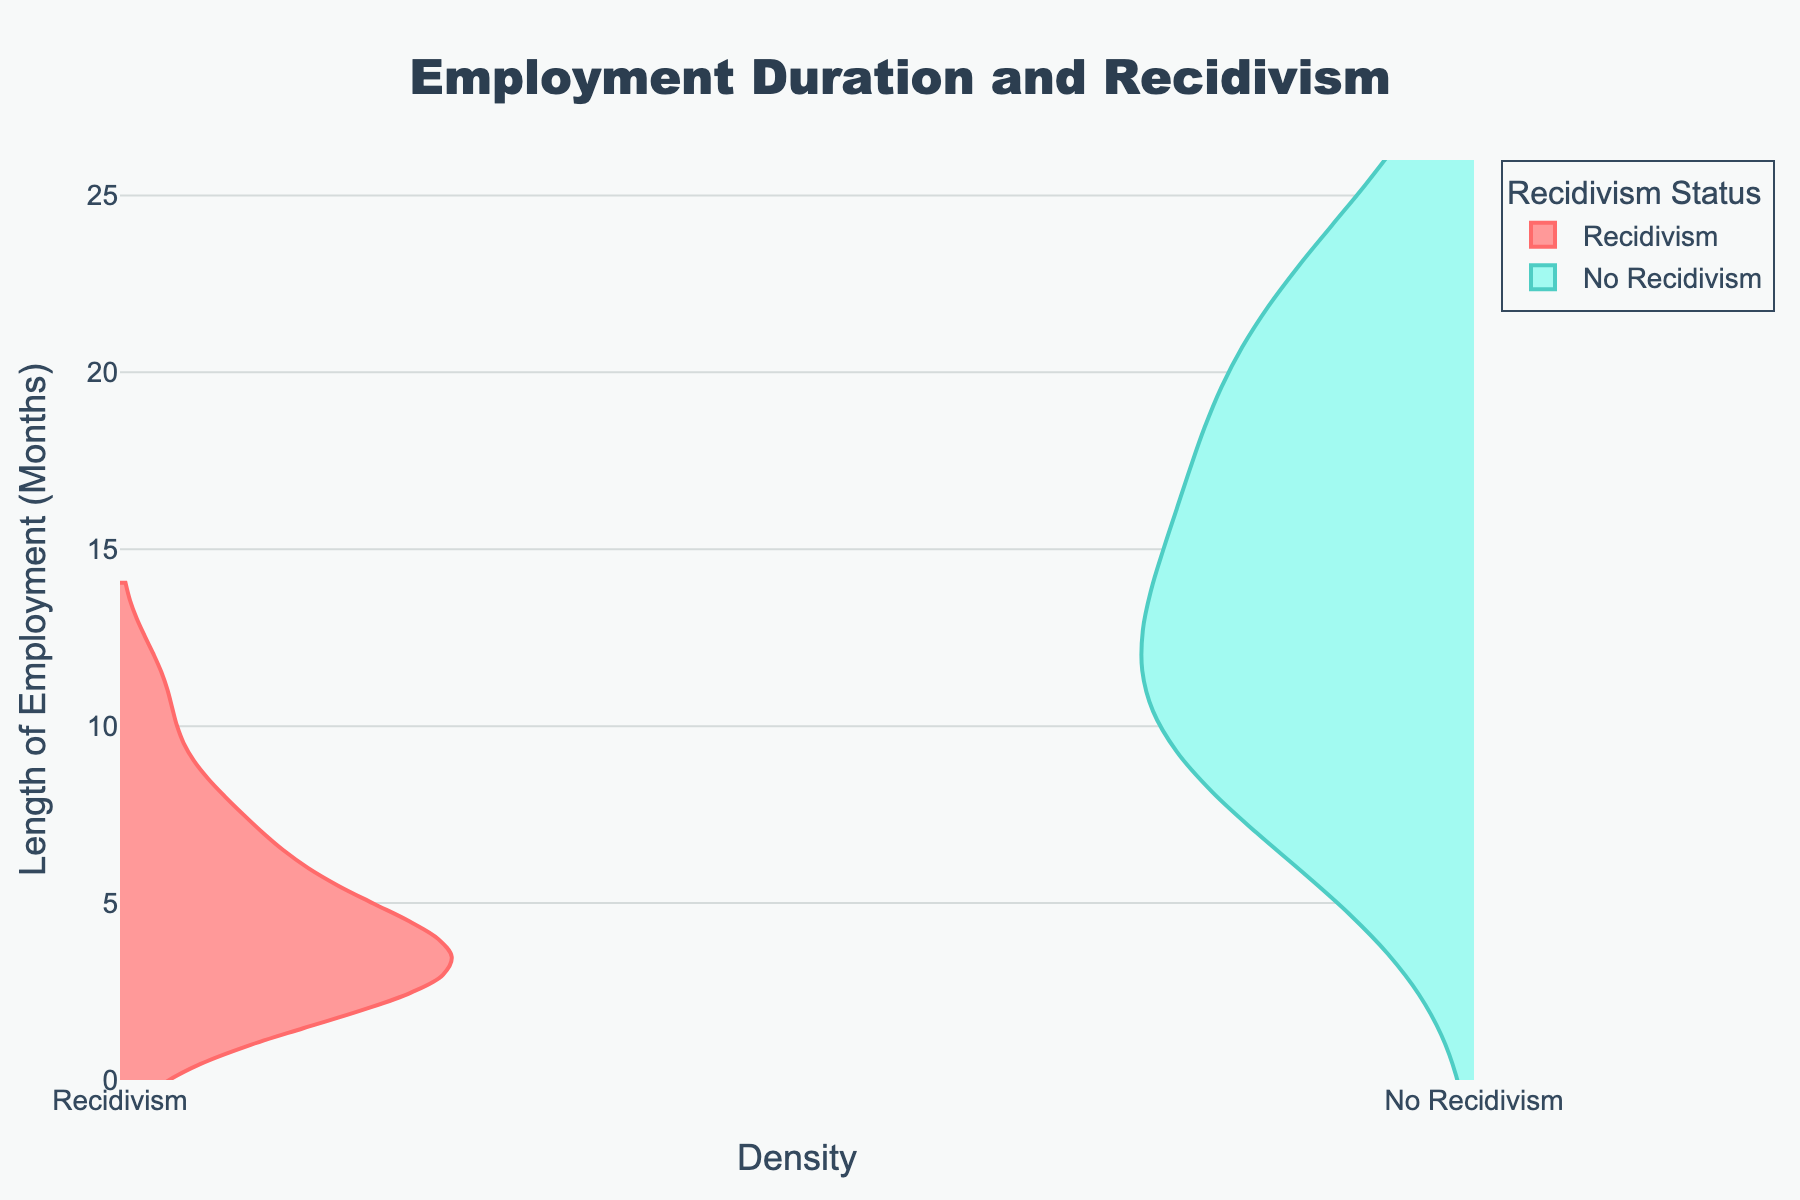What is the title of the figure? The title is typically located at the top of the figure, providing a summary of the main topic. Here, it is "Employment Duration and Recidivism," clearly describing the focus on the relationship between the length of employment and recidivism status among formerly incarcerated individuals.
Answer: Employment Duration and Recidivism What is the y-axis title of the figure? The y-axis title is found on the left side of the chart and it states the variable being measured. In this case, the y-axis title is "Length of Employment (Months)," indicating it measures how long each individual has been employed in months.
Answer: Length of Employment (Months) Which group shows a higher density for shorter employment durations (e.g., around 3 months)? By looking at the density width of the violins at shorter employment durations (around 3 months), the red-colored violin (Recidivism) shows a wider spread compared to the blue-colored violin (No Recidivism). This indicates a higher density for the Recidivism group in shorter employment durations.
Answer: Recidivism What is the maximum length of employment observed in the chart? The y-axis extends to show the range of data. The plot's y-axis ranges up to a maximum of just above 24 months, indicating 24 months as the highest observed employment duration in the data.
Answer: 24 months Is there any overlap in the employment duration range between the Recidivism and No Recidivism groups? Both violins share certain portions of the y-axis from lower to higher employment durations, indicating overlap. Therefore, there is an overlap concerning the employment duration between the two groups.
Answer: Yes What's the central tendency of employment length for individuals with no recidivism status? Observing the blue-colored violin (No Recidivism) indicates a central tendency around the midpoint (since it's thicker around that area) which is about 15 months, suggesting individuals with no recidivism tend to have this employment length.
Answer: Around 15 months Compare the density of the Recidivism and No Recidivism groups at 6 months of employment. At the employment duration of 6 months, the red-colored violin (Recidivism) is thicker compared to the blue-colored violin (No Recidivism), indicating a higher density of individuals with recidivism at this employment duration.
Answer: Recidivism What can we infer about employment duration and recidivism status based on the chart? The plot shows that individuals with recidivism tend to have shorter employment durations (higher density at shorter months), while those without recidivism show a more consistent and longer employment duration (thicker around longer months). This suggests a correlation where longer employment duration is associated with lower recidivism.
Answer: Longer employment duration is associated with lower recidivism How does the density for employees with recidivism change beyond 10 months of employment? The red-colored violin (Recidivism) becomes less thick beyond 10 months of employment, indicating fewer individuals with recidivism have longer durations of employment. The density sharply decreases after 10 months compared to shorter durations.
Answer: It decreases What is the median length of employment for the No Recidivism group? The central point or median of the blue-colored violin (No Recidivism) is located around 15 months, as indicated by the density distribution's thickest part around this value.
Answer: Around 15 months 